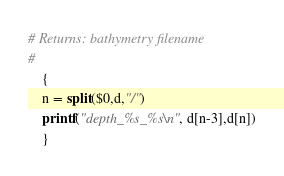Convert code to text. <code><loc_0><loc_0><loc_500><loc_500><_Awk_># Returns: bathymetry filename
#
	{
	n = split($0,d,"/")
	printf("depth_%s_%s\n", d[n-3],d[n])
	}
</code> 